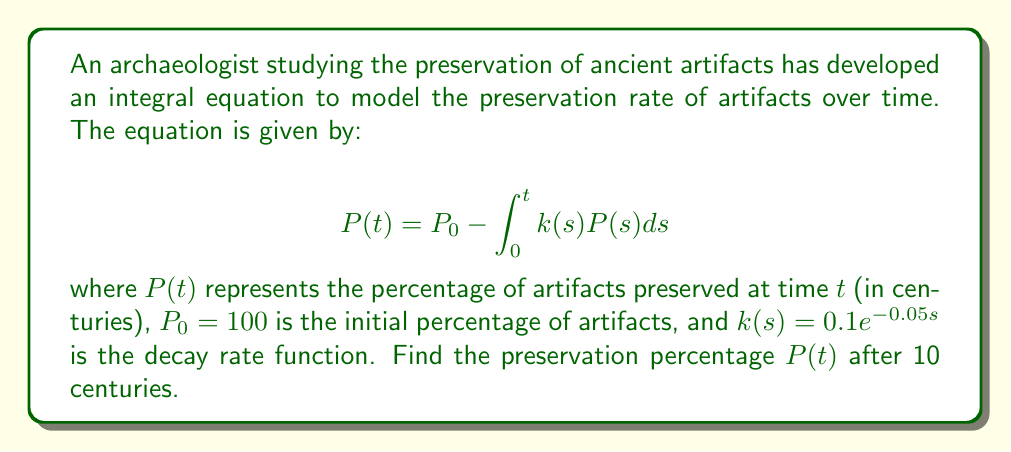What is the answer to this math problem? To solve this integral equation, we'll follow these steps:

1) First, we recognize this as a Volterra integral equation of the second kind.

2) We can solve this using the method of successive approximations (Picard iteration).

3) Let's start with the initial approximation $P_0(t) = 100$ (the initial condition).

4) We'll use this to compute the next approximation:

   $$P_1(t) = 100 - \int_0^t 0.1e^{-0.05s} \cdot 100 ds$$

5) Solving this integral:

   $$P_1(t) = 100 - 100 \cdot 0.1 \int_0^t e^{-0.05s} ds$$
   $$P_1(t) = 100 - 100 \cdot 0.1 \cdot [-20e^{-0.05s}]_0^t$$
   $$P_1(t) = 100 - 200(1 - e^{-0.05t})$$
   $$P_1(t) = 100 - 200 + 200e^{-0.05t}$$
   $$P_1(t) = 200e^{-0.05t} - 100$$

6) This is actually the exact solution to our integral equation.

7) To find the preservation percentage after 10 centuries, we substitute $t = 10$:

   $$P(10) = 200e^{-0.05 \cdot 10} - 100$$
   $$P(10) = 200e^{-0.5} - 100$$
   $$P(10) \approx 121.31 - 100 = 21.31$$

Therefore, after 10 centuries, approximately 21.31% of the artifacts would be preserved according to this model.
Answer: 21.31% 